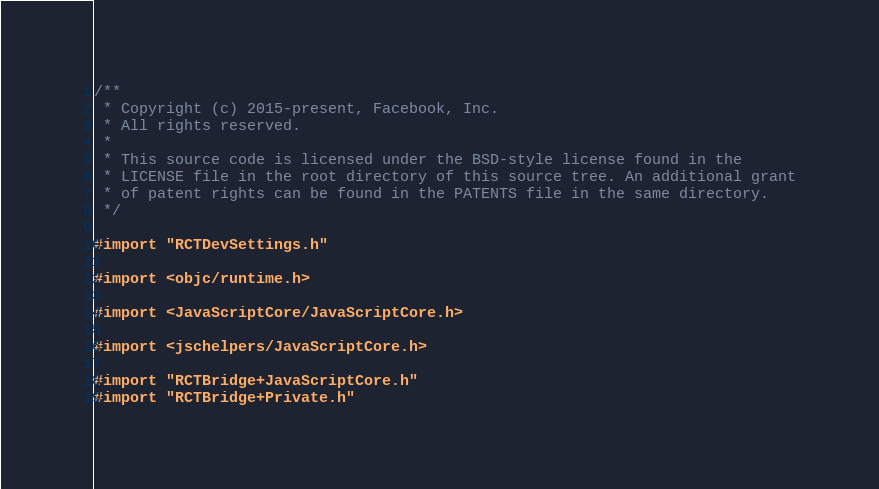Convert code to text. <code><loc_0><loc_0><loc_500><loc_500><_ObjectiveC_>/**
 * Copyright (c) 2015-present, Facebook, Inc.
 * All rights reserved.
 *
 * This source code is licensed under the BSD-style license found in the
 * LICENSE file in the root directory of this source tree. An additional grant
 * of patent rights can be found in the PATENTS file in the same directory.
 */

#import "RCTDevSettings.h"

#import <objc/runtime.h>

#import <JavaScriptCore/JavaScriptCore.h>

#import <jschelpers/JavaScriptCore.h>

#import "RCTBridge+JavaScriptCore.h"
#import "RCTBridge+Private.h"</code> 